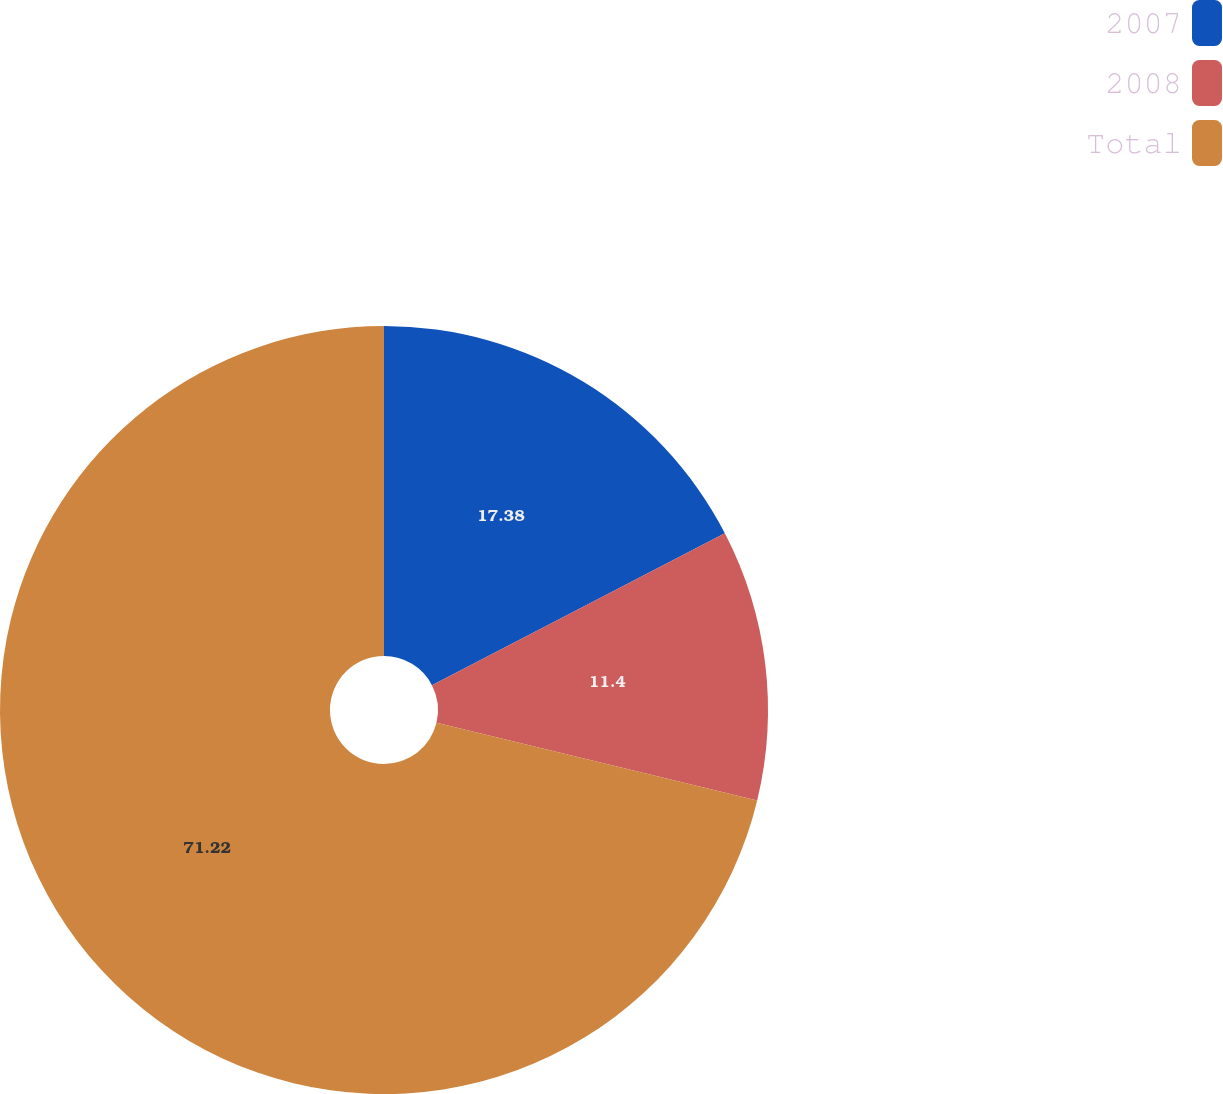Convert chart to OTSL. <chart><loc_0><loc_0><loc_500><loc_500><pie_chart><fcel>2007<fcel>2008<fcel>Total<nl><fcel>17.38%<fcel>11.4%<fcel>71.21%<nl></chart> 